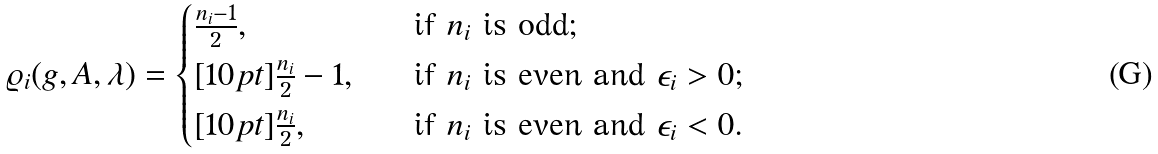<formula> <loc_0><loc_0><loc_500><loc_500>\varrho _ { i } ( g , A , \lambda ) = \begin{cases} \frac { n _ { i } - 1 } 2 , \quad & \text {if $n_{i}$ is odd;} \\ [ 1 0 p t ] \frac { n _ { i } } 2 - 1 , \quad & \text {if $n_{i}$ is even and $\epsilon_{i}>0$;} \\ [ 1 0 p t ] \frac { n _ { i } } 2 , \quad & \text {if $n_{i}$ is even and $\epsilon_{i}<0$.} \end{cases}</formula> 